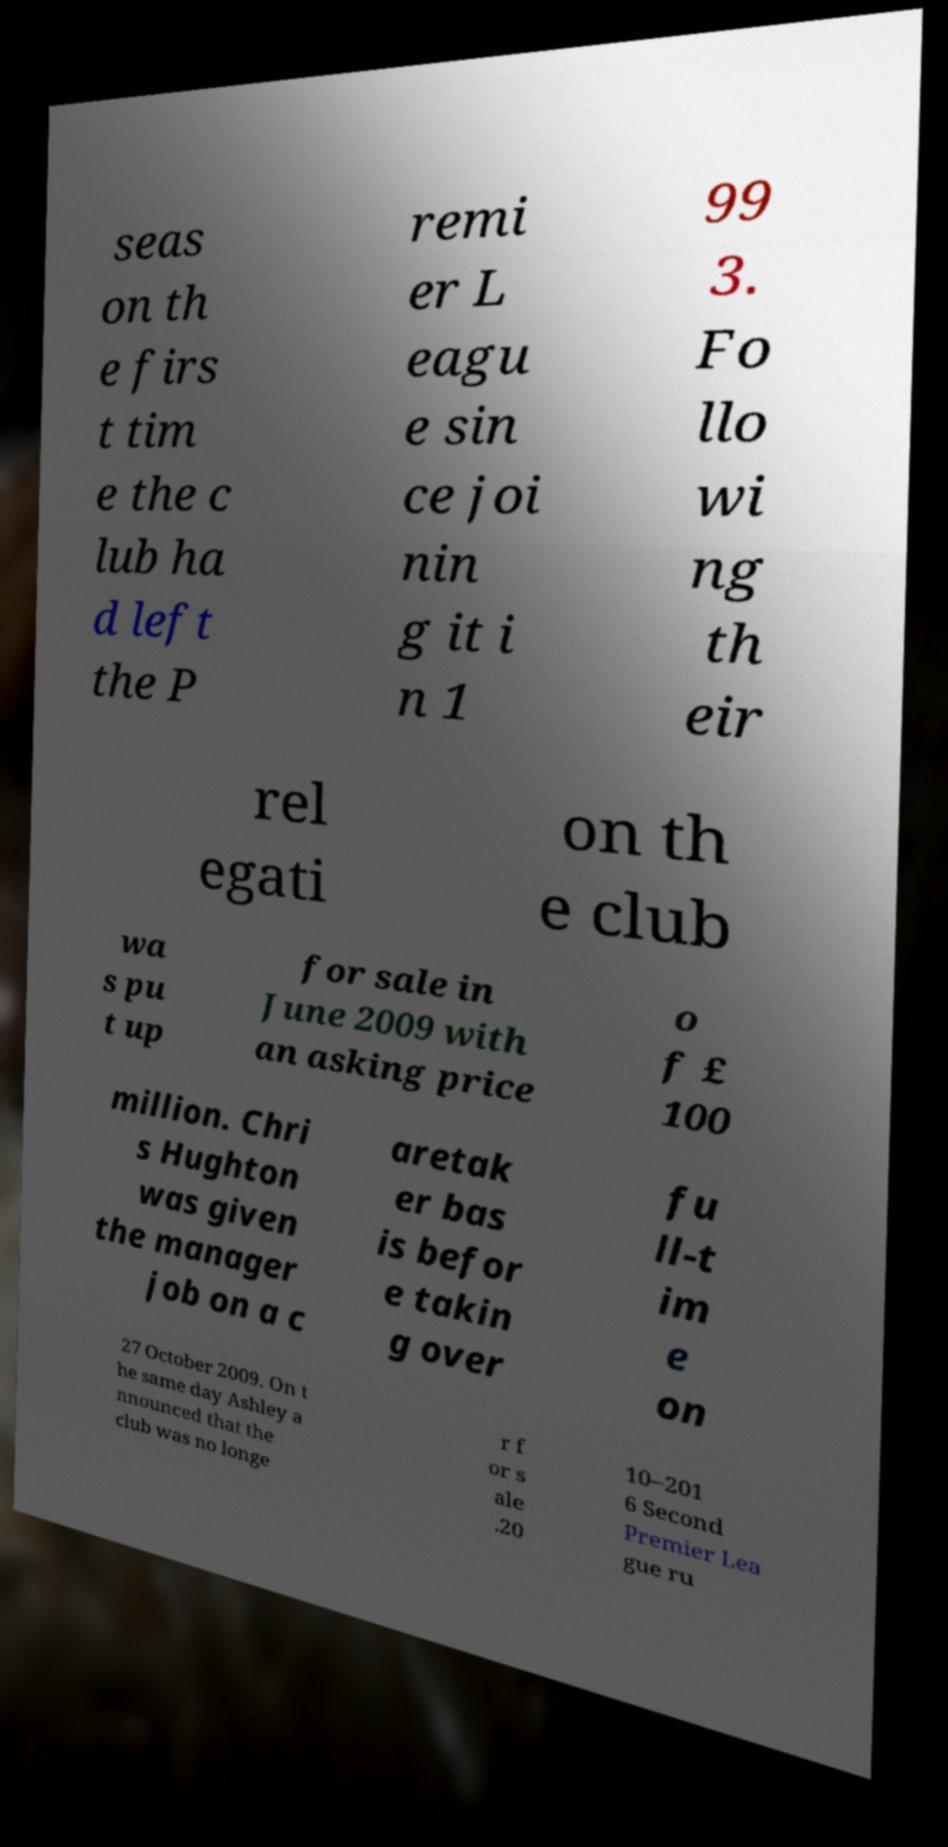What messages or text are displayed in this image? I need them in a readable, typed format. seas on th e firs t tim e the c lub ha d left the P remi er L eagu e sin ce joi nin g it i n 1 99 3. Fo llo wi ng th eir rel egati on th e club wa s pu t up for sale in June 2009 with an asking price o f £ 100 million. Chri s Hughton was given the manager job on a c aretak er bas is befor e takin g over fu ll-t im e on 27 October 2009. On t he same day Ashley a nnounced that the club was no longe r f or s ale .20 10–201 6 Second Premier Lea gue ru 